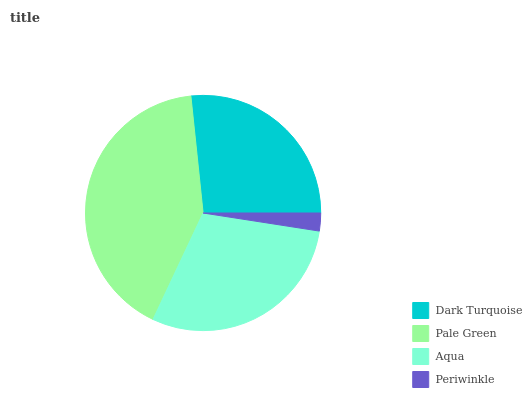Is Periwinkle the minimum?
Answer yes or no. Yes. Is Pale Green the maximum?
Answer yes or no. Yes. Is Aqua the minimum?
Answer yes or no. No. Is Aqua the maximum?
Answer yes or no. No. Is Pale Green greater than Aqua?
Answer yes or no. Yes. Is Aqua less than Pale Green?
Answer yes or no. Yes. Is Aqua greater than Pale Green?
Answer yes or no. No. Is Pale Green less than Aqua?
Answer yes or no. No. Is Aqua the high median?
Answer yes or no. Yes. Is Dark Turquoise the low median?
Answer yes or no. Yes. Is Periwinkle the high median?
Answer yes or no. No. Is Pale Green the low median?
Answer yes or no. No. 